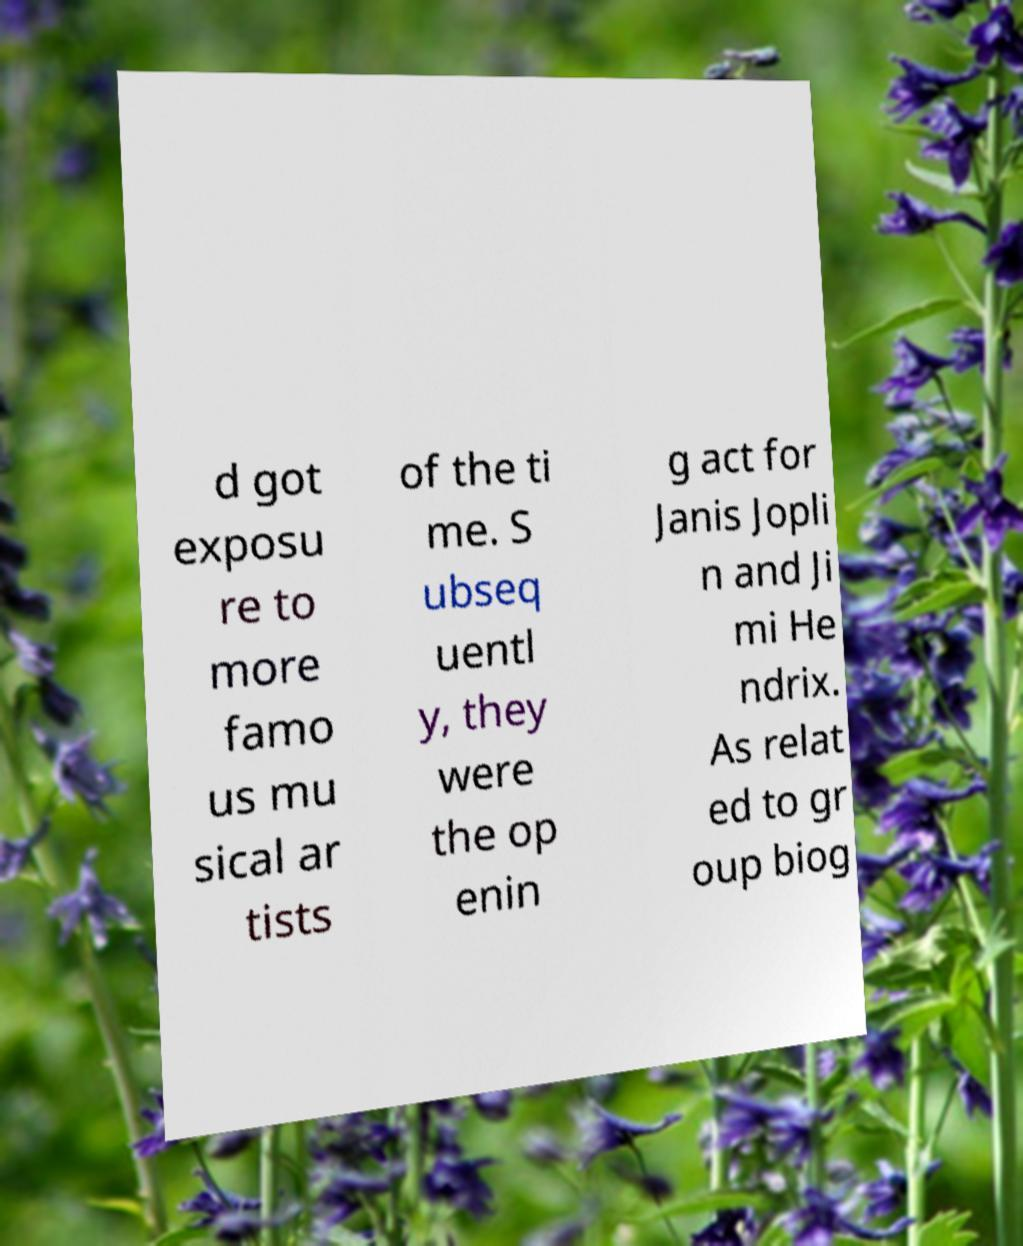Could you extract and type out the text from this image? d got exposu re to more famo us mu sical ar tists of the ti me. S ubseq uentl y, they were the op enin g act for Janis Jopli n and Ji mi He ndrix. As relat ed to gr oup biog 